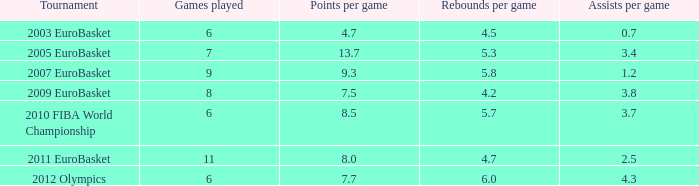How many assists per game have 4.2 rebounds per game? 3.8. 